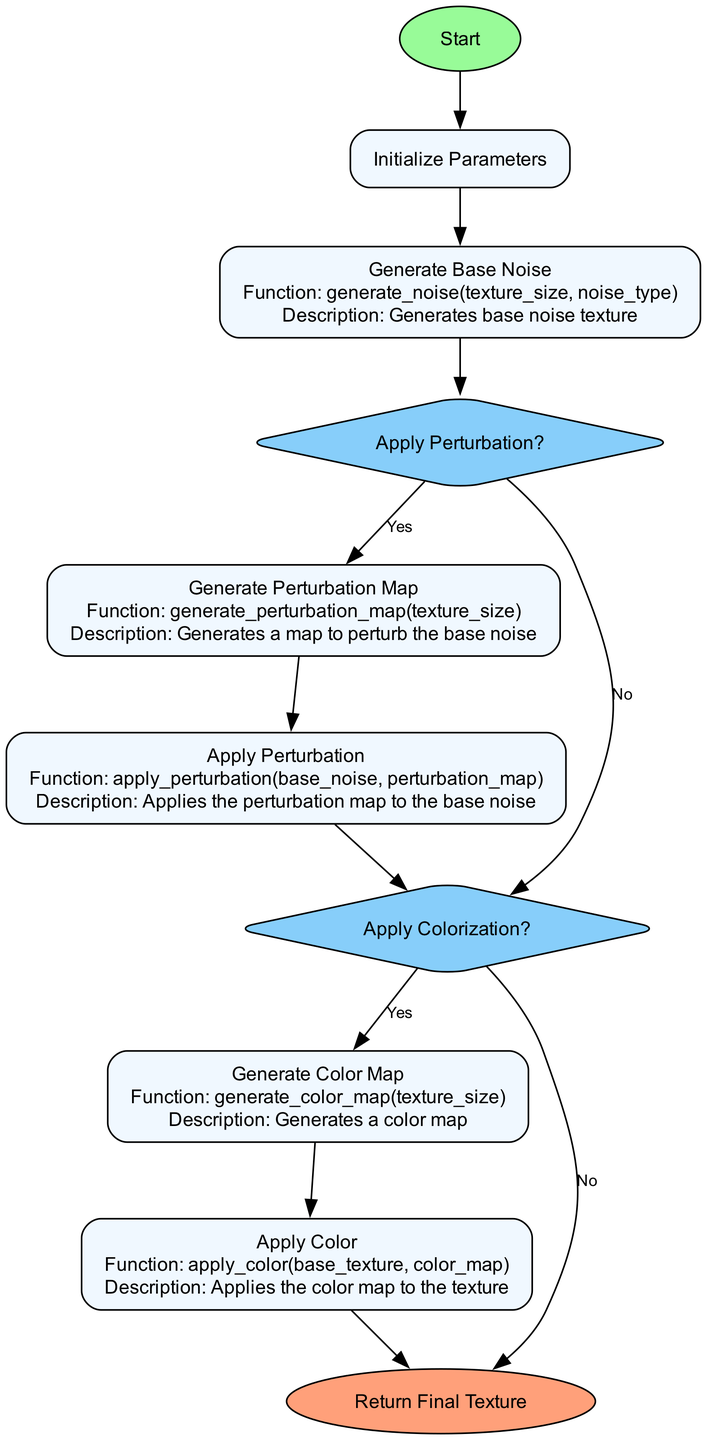What is the starting node labeled as? The diagram begins with a starting node labeled "Start". This is the initial point of the flowchart.
Answer: Start What is the size of the generated texture? In the "Initialize Parameters" process, the parameter "texture_size" is set to "(512, 512)", which indicates the size of the texture.
Answer: (512, 512) How many processes are there in the diagram? The diagram includes six process nodes: "Initialize Parameters", "Generate Base Noise", "Generate Perturbation Map", "Apply Perturbation", "Generate Color Map", and "Apply Color". Counting these gives a total of six processes.
Answer: 6 What is the decision made after generating base noise? After the "Generate Base Noise" node, a decision is made labeled "Apply Perturbation?". This evaluates whether perturbation is to be applied or not.
Answer: Apply Perturbation? What happens if the decision to apply colorization is "No"? If the decision in the "Apply Colorization?" node is "No", the flow proceeds directly to the "Return Final Texture" node, which indicates the end of the process.
Answer: Return Final Texture What is the function called to generate the perturbation map? The function used to generate the perturbation map is "generate_perturbation_map(texture_size)". This function creates a map that alters the base noise.
Answer: generate_perturbation_map(texture_size) If perturbation is applied, which nodes are executed next? If the answer to "Apply Perturbation?" is "Yes", the flow moves to "Generate Perturbation Map" followed by "Apply Perturbation". Therefore, both nodes will be executed.
Answer: Generate Perturbation Map, Apply Perturbation What color map function is called in the flowchart? The flowchart specifies the function "generate_color_map(texture_size)" in the process of generating the color map. This function is essential for creating a color map based on texture size.
Answer: generate_color_map(texture_size) What type of flowchart is represented in this diagram? The diagram represents a flowchart of a Python function specifically for dynamic texture generation related to procedural materials in game rendering.
Answer: Flowchart of a Python Function for Dynamic Texture Generation 